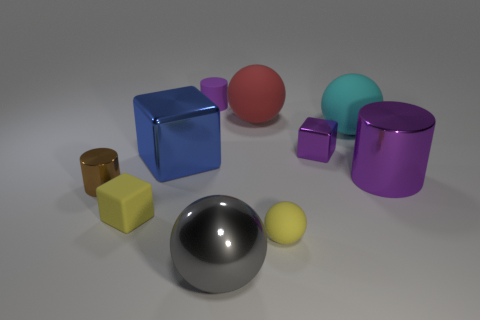Can you comment on the composition and balance of the image? Certainly, the image is composed with a balanced arrangement of shapes and colors, utilizing both symmetry and asymmetry. Objects are strategically placed to lead the viewer's eye through the scene, with a variation in size and color that provides visual interest without overwhelming the viewer. 